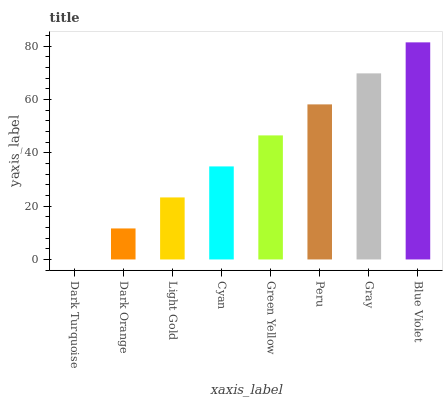Is Dark Turquoise the minimum?
Answer yes or no. Yes. Is Blue Violet the maximum?
Answer yes or no. Yes. Is Dark Orange the minimum?
Answer yes or no. No. Is Dark Orange the maximum?
Answer yes or no. No. Is Dark Orange greater than Dark Turquoise?
Answer yes or no. Yes. Is Dark Turquoise less than Dark Orange?
Answer yes or no. Yes. Is Dark Turquoise greater than Dark Orange?
Answer yes or no. No. Is Dark Orange less than Dark Turquoise?
Answer yes or no. No. Is Green Yellow the high median?
Answer yes or no. Yes. Is Cyan the low median?
Answer yes or no. Yes. Is Dark Orange the high median?
Answer yes or no. No. Is Green Yellow the low median?
Answer yes or no. No. 